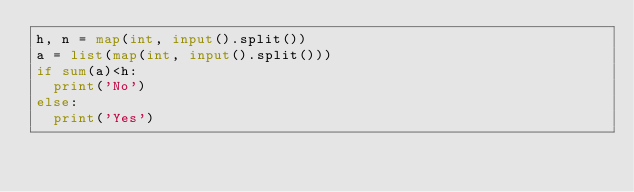<code> <loc_0><loc_0><loc_500><loc_500><_Python_>h, n = map(int, input().split())
a = list(map(int, input().split()))
if sum(a)<h:
  print('No')
else:
  print('Yes')</code> 